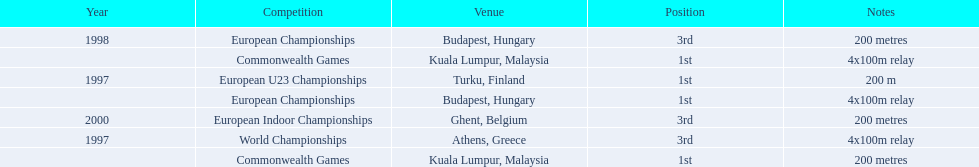How many total years did golding compete? 3. 